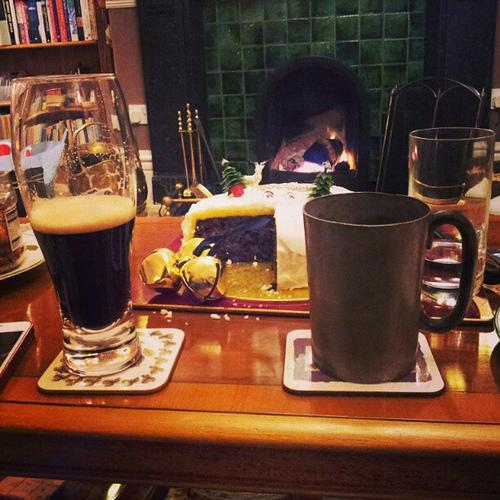Provide a brief description of the overall scene in the image. The image shows a cozy setting with a wooden table hosting various beverages, a cake, and gadgets, with a burning fireplace and bookshelf in the background. Describe the fireplace setting in the image, including nearby items. The fireplace setting includes a blazing fire in the background, fireplace pokers beside the fire, and a gate covering the fireplace opening. What is the central object on the wooden table and what is its color? The central object on the wooden table is a dark cake with white frosting. How many fire-related items are in the image and what are they? There are three fire-related items: fire in the fireplace, blazing fireplace in the back, and a fire place burning in the background. List all the objects present on the wooden table. glass of water, mottled metal cup, dark beverage, dark cake with white frosting, glass setting on a coaster, glass half full with brown drink, coffee mug setting on a table, cake setting on table with huge piece missing, small coaster on table, iPhone on table, cell phone on wood table, cake in middle of table. Mention the prominent beverage in the image and describe its appearance. The prominent beverage in the image is a tall glass of dark brown beer with a small foamy head. Identify two objects on the table that are associated with Christmas. Holiday cake with Christmas trees sticking out of the top and cluster of three large jingle bells. What type of cake is displayed in the image and how is it decorated? A holiday cake with white icing is displayed, it has a large piece missing and Christmas trees sticking out of the top. Describe a notable interaction between objects in the image. A grey mug and a glass of dark brown beer are placed on separate square coasters, protecting the brown wooden table beneath them. What is the main purpose of the objects placed on the square coasters? The main purpose of the objects placed on the square coasters is to prevent spill marks or damage to the wooden table. Point out the small blue bird perched on the edge of the fireplace and mention the type of bird it is. The given information includes a fireplace but does not mention anything about a bird. By asking the user to determine the type of bird, this instruction creates further confusion and distracts from the actual objects in the image. Describe the glass of water. The glass of water is placed on the table with its left-top corner coordinates at X:404 and Y:124, having a width of 90 and a height of 90. What is the purpose of the yellow metal fireplace pokers? The yellow metal fireplace pokers are used to adjust and manipulate burning logs inside the fireplace for safety purposes. Find the reference for the "delicious cake with a large piece missing." The delicious cake with a large piece missing has its left-top corner coordinates at X:182 and Y:178, with a width of 200 and a height of 200. Could you see the purple umbrella leaning against the wall behind the chair? State the shade of purple it is. No, it's not mentioned in the image. Which object is larger, the coffee mug setting on a table or the glass of water on the table? The coffee mug setting on a table (X:301, Y:191, Width:176, Height:176) is larger than the glass of water on the table (X:397, Y:119, Width:101, Height:101). Is the fire in the fireplace lit or not? Yes, the fire in the fireplace is lit. How many objects are placed on the wooden table? There are at least 6 objects placed on the wooden table - two glasses, two coasters, a mug, and a cake. Identify any unusual or unexpected features in this image. There are no significant anomalies in the image. All objects are coherent and reasonably placed. What emotions or sentiment does this image evoke? The image evokes a warm, cozy, and festive atmosphere due to the fire in the fireplace, holiday cake, and decorations. Describe the attributes of the green tiles on the wall. The green tiles on the wall are positioned at X:206 and Y:21, with a width of 111 and a height of 111. Segment and label the objects in the image based on semantic understanding. - Glass of water, Spot the dolphin figurine sitting next to the cake on the table, and note its color and dimensions. The given information does not mention any dolphin figurine being present in the image. By asking the user to look for its color and dimensions, it leads the user to be more focused on finding that nonexistent item. What kind of drink is in the tall glass? The tall glass contains a dark brown beer. Can you identify the bouquet of flowers in the top-left corner of the image? Make sure you zoom in to see them clearly. There are no details about a bouquet of flowers in the given information. By asking the user to zoom in, it creates the illusion that the flowers may be very small or hard to see, when in fact, they don't exist in the image. Evaluate the clarity and quality of this image. The image has a good clarity, with distinct objects and their properties easily identifiable. Which object is closest to the cluster of three large jingle bells? The cake setting on the table with a huge piece missing is closest to the cluster of three large jingle bells. What is the setting or environment in which this image takes place? The setting is an indoor room with a fireplace, wooden table, bookshelf, and various decorative items. What material is the chair with high metal back made of? The chair has a metal back. What is the position and size of the dark cake with white frosting? The dark cake with white frosting is positioned at X:179 and Y:180 with a width of 181 and a height of 181. What are the interactions between the glass of dark beverage and the coaster it is placed on? The glass of dark beverage is placed on the coaster, which supports and protects the table from potential condensation or spills. Is there any text or writing visible in the image? No, there is no text or writing present in the image. What is the position and size of the grey mug on the coaster? The grey mug on the coaster is positioned at X:305 and Y:185, with a width of 163 and a height of 163. Describe the placement of the iphone on the table. The iphone is placed on the table with its left-top corner coordinates at X:0 and Y:316, having a width of 33 and a height of 33. 